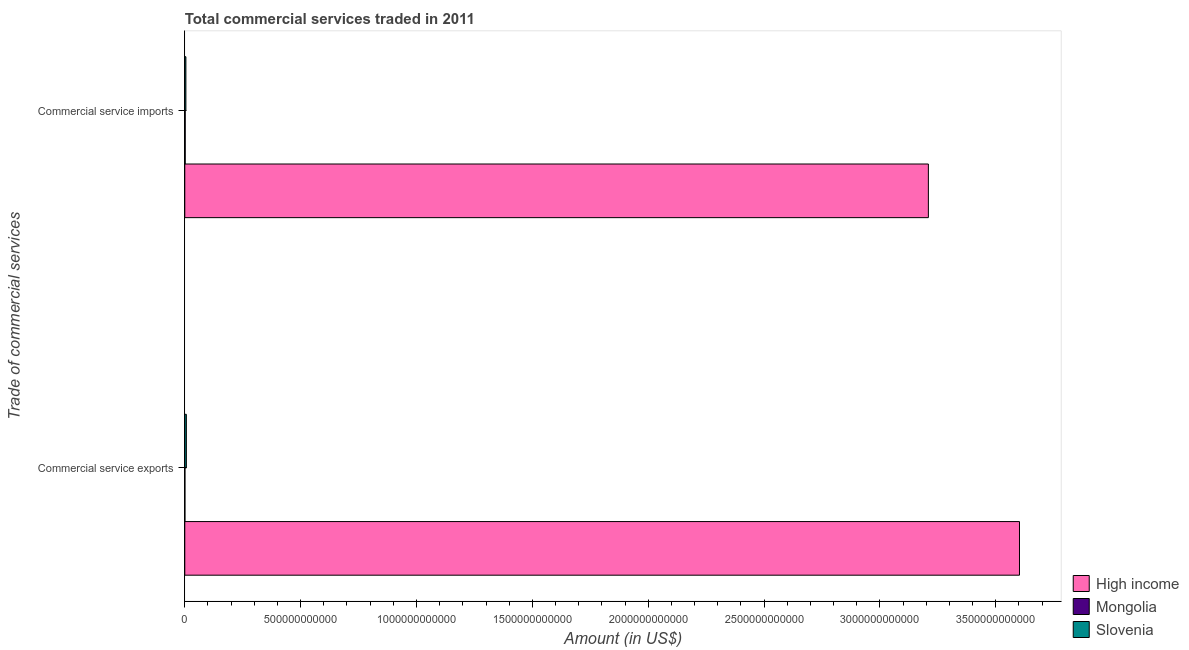How many groups of bars are there?
Your answer should be very brief. 2. Are the number of bars per tick equal to the number of legend labels?
Give a very brief answer. Yes. How many bars are there on the 1st tick from the bottom?
Ensure brevity in your answer.  3. What is the label of the 2nd group of bars from the top?
Ensure brevity in your answer.  Commercial service exports. What is the amount of commercial service exports in High income?
Your response must be concise. 3.60e+12. Across all countries, what is the maximum amount of commercial service imports?
Offer a terse response. 3.21e+12. Across all countries, what is the minimum amount of commercial service exports?
Provide a short and direct response. 6.17e+08. In which country was the amount of commercial service imports maximum?
Provide a succinct answer. High income. In which country was the amount of commercial service exports minimum?
Your answer should be compact. Mongolia. What is the total amount of commercial service exports in the graph?
Your answer should be very brief. 3.61e+12. What is the difference between the amount of commercial service exports in Slovenia and that in High income?
Ensure brevity in your answer.  -3.60e+12. What is the difference between the amount of commercial service exports in Mongolia and the amount of commercial service imports in Slovenia?
Your answer should be compact. -4.15e+09. What is the average amount of commercial service imports per country?
Offer a very short reply. 1.07e+12. What is the difference between the amount of commercial service imports and amount of commercial service exports in High income?
Offer a terse response. -3.93e+11. What is the ratio of the amount of commercial service imports in Mongolia to that in High income?
Provide a short and direct response. 0. Is the amount of commercial service exports in Mongolia less than that in Slovenia?
Make the answer very short. Yes. In how many countries, is the amount of commercial service exports greater than the average amount of commercial service exports taken over all countries?
Give a very brief answer. 1. What does the 1st bar from the top in Commercial service imports represents?
Your response must be concise. Slovenia. What does the 3rd bar from the bottom in Commercial service imports represents?
Your answer should be very brief. Slovenia. How many bars are there?
Provide a short and direct response. 6. Are all the bars in the graph horizontal?
Offer a terse response. Yes. What is the difference between two consecutive major ticks on the X-axis?
Provide a succinct answer. 5.00e+11. Does the graph contain any zero values?
Keep it short and to the point. No. Does the graph contain grids?
Your answer should be very brief. No. What is the title of the graph?
Your answer should be compact. Total commercial services traded in 2011. Does "San Marino" appear as one of the legend labels in the graph?
Your answer should be compact. No. What is the label or title of the X-axis?
Your answer should be compact. Amount (in US$). What is the label or title of the Y-axis?
Keep it short and to the point. Trade of commercial services. What is the Amount (in US$) of High income in Commercial service exports?
Your answer should be compact. 3.60e+12. What is the Amount (in US$) in Mongolia in Commercial service exports?
Give a very brief answer. 6.17e+08. What is the Amount (in US$) of Slovenia in Commercial service exports?
Provide a succinct answer. 6.82e+09. What is the Amount (in US$) of High income in Commercial service imports?
Your answer should be compact. 3.21e+12. What is the Amount (in US$) of Mongolia in Commercial service imports?
Provide a short and direct response. 1.77e+09. What is the Amount (in US$) in Slovenia in Commercial service imports?
Your answer should be compact. 4.77e+09. Across all Trade of commercial services, what is the maximum Amount (in US$) of High income?
Your answer should be very brief. 3.60e+12. Across all Trade of commercial services, what is the maximum Amount (in US$) of Mongolia?
Your answer should be compact. 1.77e+09. Across all Trade of commercial services, what is the maximum Amount (in US$) of Slovenia?
Offer a very short reply. 6.82e+09. Across all Trade of commercial services, what is the minimum Amount (in US$) of High income?
Make the answer very short. 3.21e+12. Across all Trade of commercial services, what is the minimum Amount (in US$) in Mongolia?
Offer a very short reply. 6.17e+08. Across all Trade of commercial services, what is the minimum Amount (in US$) of Slovenia?
Your answer should be very brief. 4.77e+09. What is the total Amount (in US$) in High income in the graph?
Make the answer very short. 6.81e+12. What is the total Amount (in US$) of Mongolia in the graph?
Keep it short and to the point. 2.39e+09. What is the total Amount (in US$) of Slovenia in the graph?
Provide a short and direct response. 1.16e+1. What is the difference between the Amount (in US$) in High income in Commercial service exports and that in Commercial service imports?
Give a very brief answer. 3.93e+11. What is the difference between the Amount (in US$) in Mongolia in Commercial service exports and that in Commercial service imports?
Your answer should be compact. -1.15e+09. What is the difference between the Amount (in US$) in Slovenia in Commercial service exports and that in Commercial service imports?
Offer a very short reply. 2.05e+09. What is the difference between the Amount (in US$) of High income in Commercial service exports and the Amount (in US$) of Mongolia in Commercial service imports?
Keep it short and to the point. 3.60e+12. What is the difference between the Amount (in US$) of High income in Commercial service exports and the Amount (in US$) of Slovenia in Commercial service imports?
Provide a short and direct response. 3.60e+12. What is the difference between the Amount (in US$) of Mongolia in Commercial service exports and the Amount (in US$) of Slovenia in Commercial service imports?
Keep it short and to the point. -4.15e+09. What is the average Amount (in US$) of High income per Trade of commercial services?
Your answer should be very brief. 3.41e+12. What is the average Amount (in US$) in Mongolia per Trade of commercial services?
Ensure brevity in your answer.  1.19e+09. What is the average Amount (in US$) of Slovenia per Trade of commercial services?
Give a very brief answer. 5.80e+09. What is the difference between the Amount (in US$) in High income and Amount (in US$) in Mongolia in Commercial service exports?
Offer a terse response. 3.60e+12. What is the difference between the Amount (in US$) in High income and Amount (in US$) in Slovenia in Commercial service exports?
Ensure brevity in your answer.  3.60e+12. What is the difference between the Amount (in US$) of Mongolia and Amount (in US$) of Slovenia in Commercial service exports?
Offer a terse response. -6.20e+09. What is the difference between the Amount (in US$) of High income and Amount (in US$) of Mongolia in Commercial service imports?
Your response must be concise. 3.21e+12. What is the difference between the Amount (in US$) in High income and Amount (in US$) in Slovenia in Commercial service imports?
Provide a short and direct response. 3.20e+12. What is the difference between the Amount (in US$) of Mongolia and Amount (in US$) of Slovenia in Commercial service imports?
Your answer should be very brief. -3.00e+09. What is the ratio of the Amount (in US$) of High income in Commercial service exports to that in Commercial service imports?
Your response must be concise. 1.12. What is the ratio of the Amount (in US$) of Mongolia in Commercial service exports to that in Commercial service imports?
Provide a succinct answer. 0.35. What is the ratio of the Amount (in US$) in Slovenia in Commercial service exports to that in Commercial service imports?
Your answer should be compact. 1.43. What is the difference between the highest and the second highest Amount (in US$) of High income?
Offer a terse response. 3.93e+11. What is the difference between the highest and the second highest Amount (in US$) of Mongolia?
Provide a short and direct response. 1.15e+09. What is the difference between the highest and the second highest Amount (in US$) in Slovenia?
Provide a succinct answer. 2.05e+09. What is the difference between the highest and the lowest Amount (in US$) in High income?
Give a very brief answer. 3.93e+11. What is the difference between the highest and the lowest Amount (in US$) of Mongolia?
Your response must be concise. 1.15e+09. What is the difference between the highest and the lowest Amount (in US$) of Slovenia?
Offer a very short reply. 2.05e+09. 